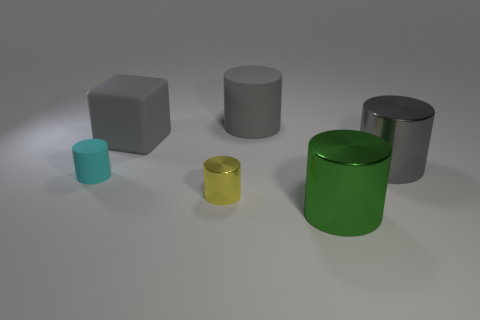Do the big cylinder to the right of the green object and the big gray cube have the same material?
Offer a very short reply. No. What is the size of the object that is both in front of the gray metallic cylinder and left of the small yellow cylinder?
Your response must be concise. Small. What is the color of the big rubber cylinder?
Offer a very short reply. Gray. How many yellow shiny things are there?
Your response must be concise. 1. What number of big matte objects are the same color as the small shiny object?
Keep it short and to the point. 0. Is the shape of the thing that is in front of the small yellow thing the same as the big object to the left of the yellow thing?
Offer a terse response. No. What is the color of the small metallic thing that is in front of the large thing left of the small cylinder that is on the right side of the cyan rubber cylinder?
Keep it short and to the point. Yellow. There is a rubber object in front of the gray rubber cube; what is its color?
Your response must be concise. Cyan. What is the color of the cylinder that is the same size as the cyan thing?
Ensure brevity in your answer.  Yellow. Do the green thing and the cyan rubber thing have the same size?
Offer a terse response. No. 